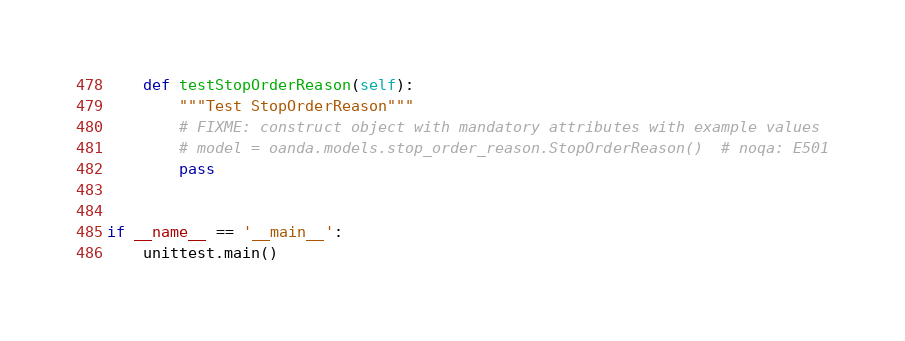Convert code to text. <code><loc_0><loc_0><loc_500><loc_500><_Python_>    def testStopOrderReason(self):
        """Test StopOrderReason"""
        # FIXME: construct object with mandatory attributes with example values
        # model = oanda.models.stop_order_reason.StopOrderReason()  # noqa: E501
        pass


if __name__ == '__main__':
    unittest.main()
</code> 